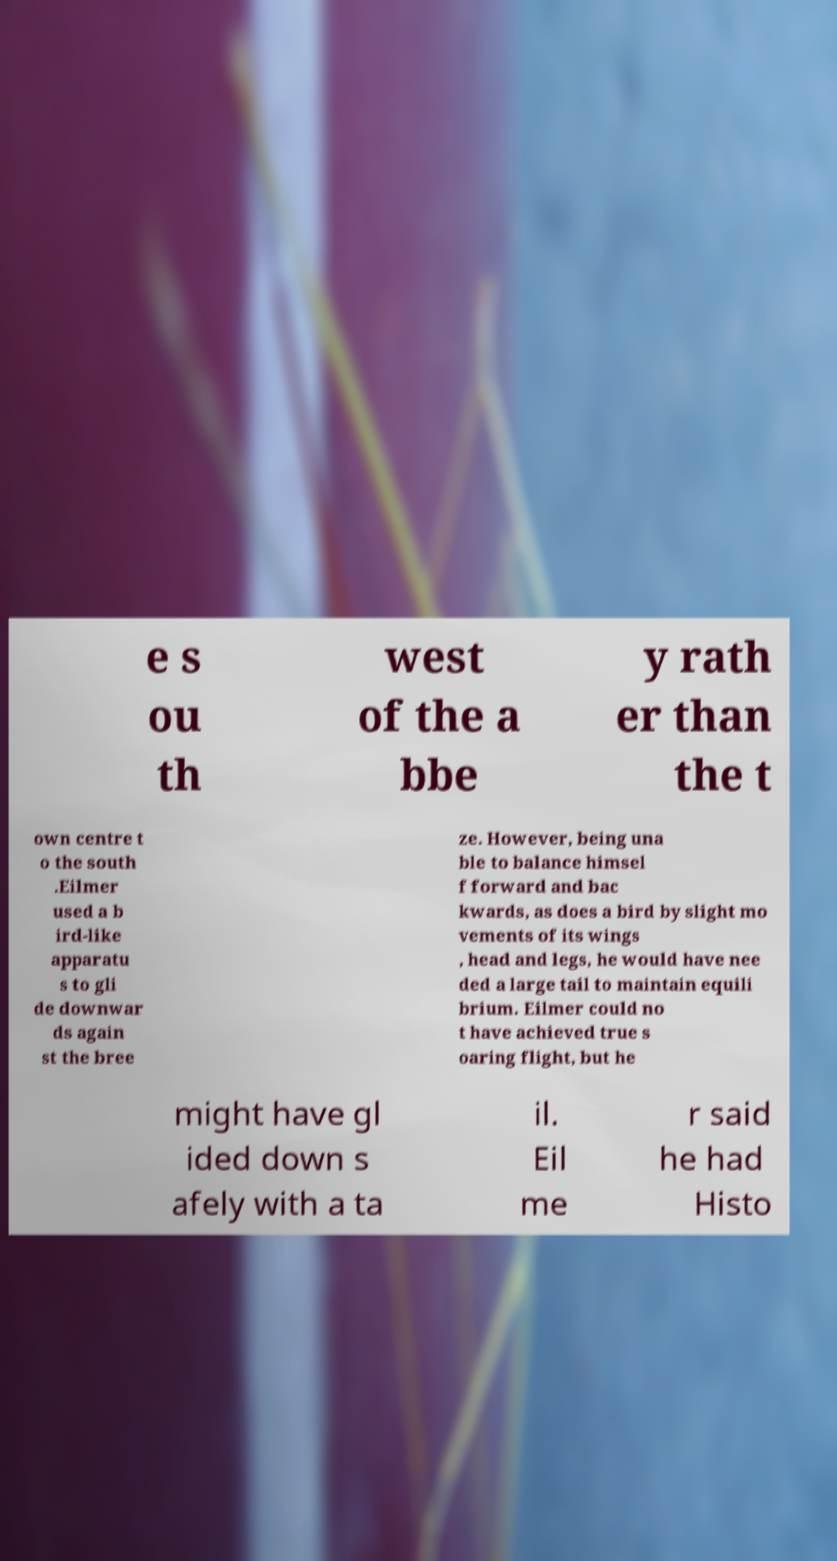Can you read and provide the text displayed in the image?This photo seems to have some interesting text. Can you extract and type it out for me? e s ou th west of the a bbe y rath er than the t own centre t o the south .Eilmer used a b ird-like apparatu s to gli de downwar ds again st the bree ze. However, being una ble to balance himsel f forward and bac kwards, as does a bird by slight mo vements of its wings , head and legs, he would have nee ded a large tail to maintain equili brium. Eilmer could no t have achieved true s oaring flight, but he might have gl ided down s afely with a ta il. Eil me r said he had Histo 